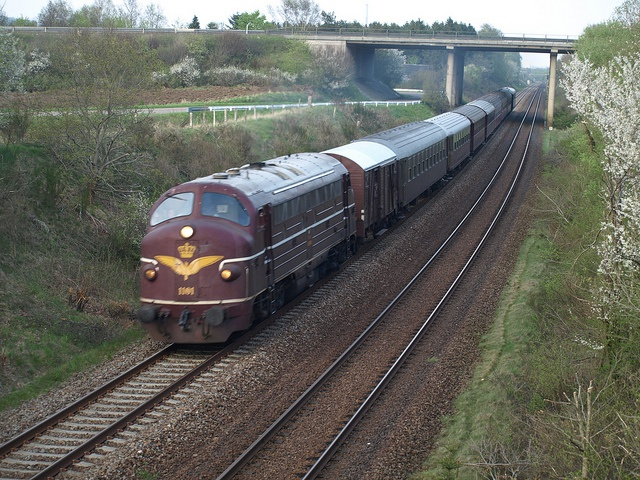Describe the objects in this image and their specific colors. I can see a train in white, black, gray, and lightgray tones in this image. 